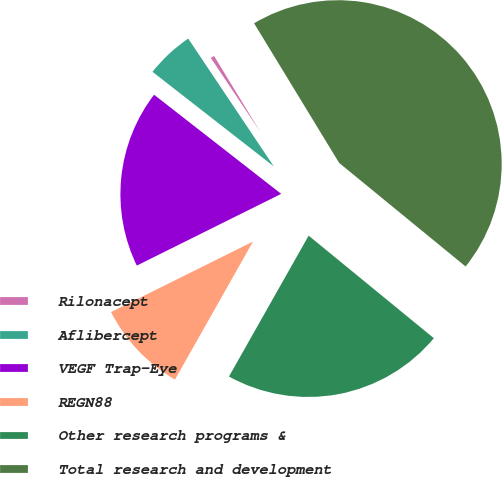<chart> <loc_0><loc_0><loc_500><loc_500><pie_chart><fcel>Rilonacept<fcel>Aflibercept<fcel>VEGF Trap-Eye<fcel>REGN88<fcel>Other research programs &<fcel>Total research and development<nl><fcel>0.68%<fcel>5.07%<fcel>17.88%<fcel>9.47%<fcel>22.27%<fcel>44.63%<nl></chart> 